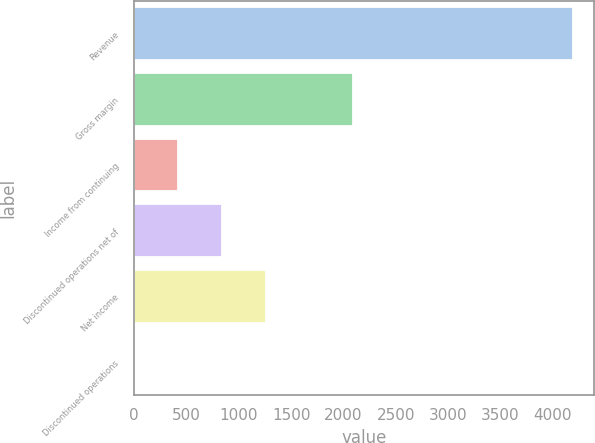Convert chart to OTSL. <chart><loc_0><loc_0><loc_500><loc_500><bar_chart><fcel>Revenue<fcel>Gross margin<fcel>Income from continuing<fcel>Discontinued operations net of<fcel>Net income<fcel>Discontinued operations<nl><fcel>4189<fcel>2094.52<fcel>418.92<fcel>837.82<fcel>1256.72<fcel>0.02<nl></chart> 